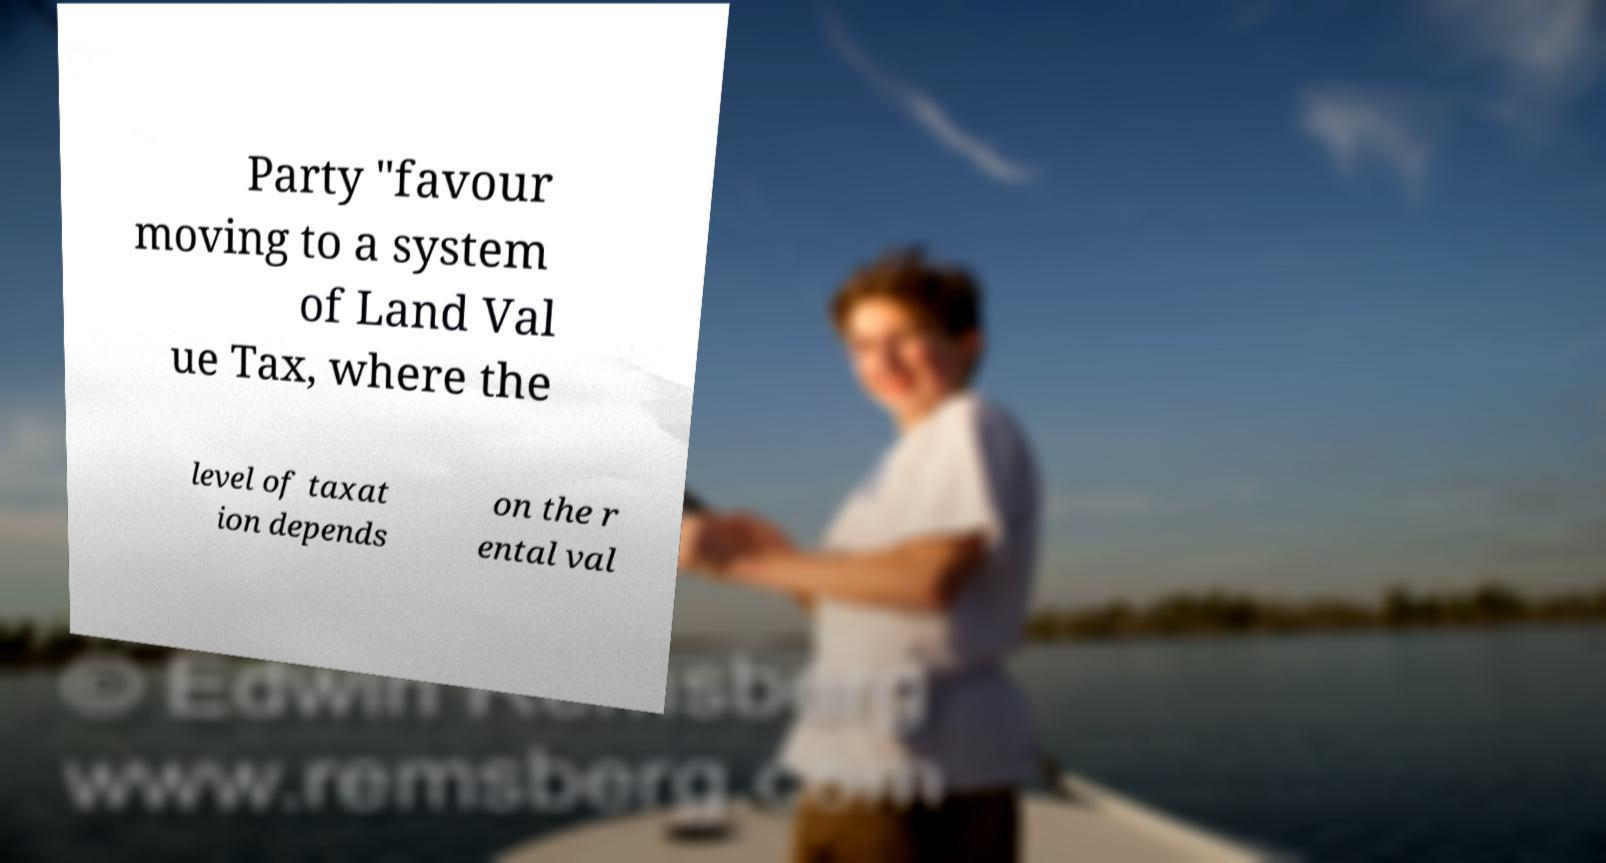Can you accurately transcribe the text from the provided image for me? Party "favour moving to a system of Land Val ue Tax, where the level of taxat ion depends on the r ental val 